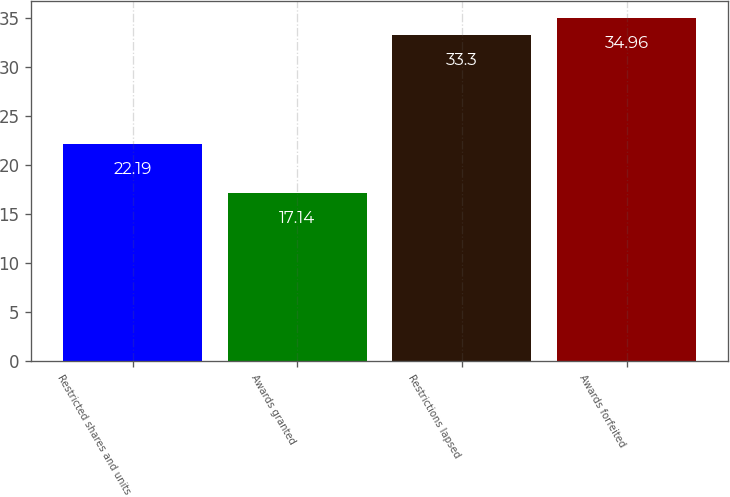<chart> <loc_0><loc_0><loc_500><loc_500><bar_chart><fcel>Restricted shares and units<fcel>Awards granted<fcel>Restrictions lapsed<fcel>Awards forfeited<nl><fcel>22.19<fcel>17.14<fcel>33.3<fcel>34.96<nl></chart> 